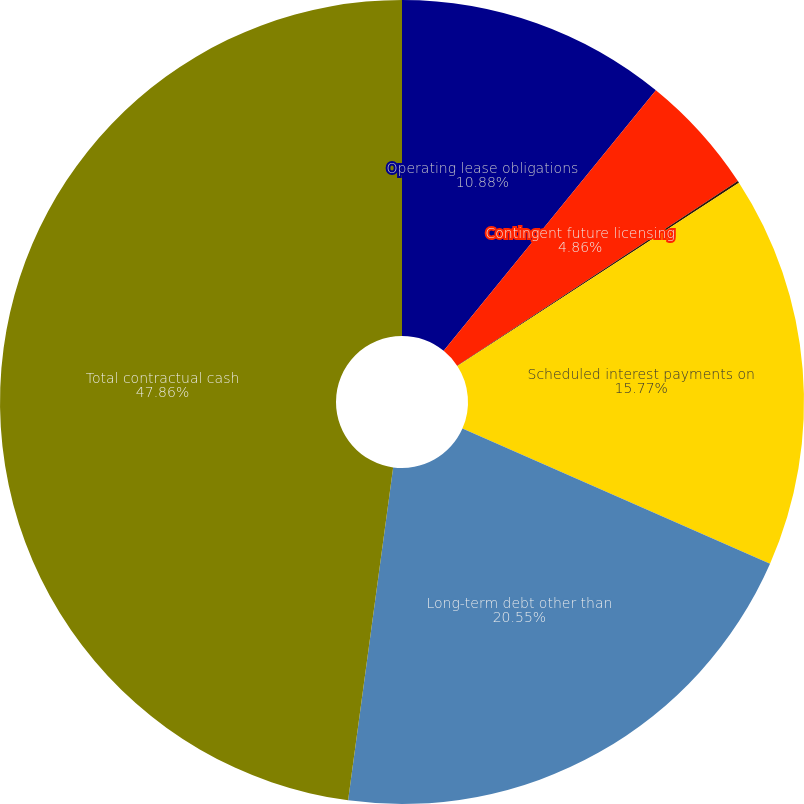<chart> <loc_0><loc_0><loc_500><loc_500><pie_chart><fcel>Operating lease obligations<fcel>Contingent future licensing<fcel>Minimum royalty payments<fcel>Scheduled interest payments on<fcel>Long-term debt other than<fcel>Total contractual cash<nl><fcel>10.88%<fcel>4.86%<fcel>0.08%<fcel>15.77%<fcel>20.55%<fcel>47.86%<nl></chart> 